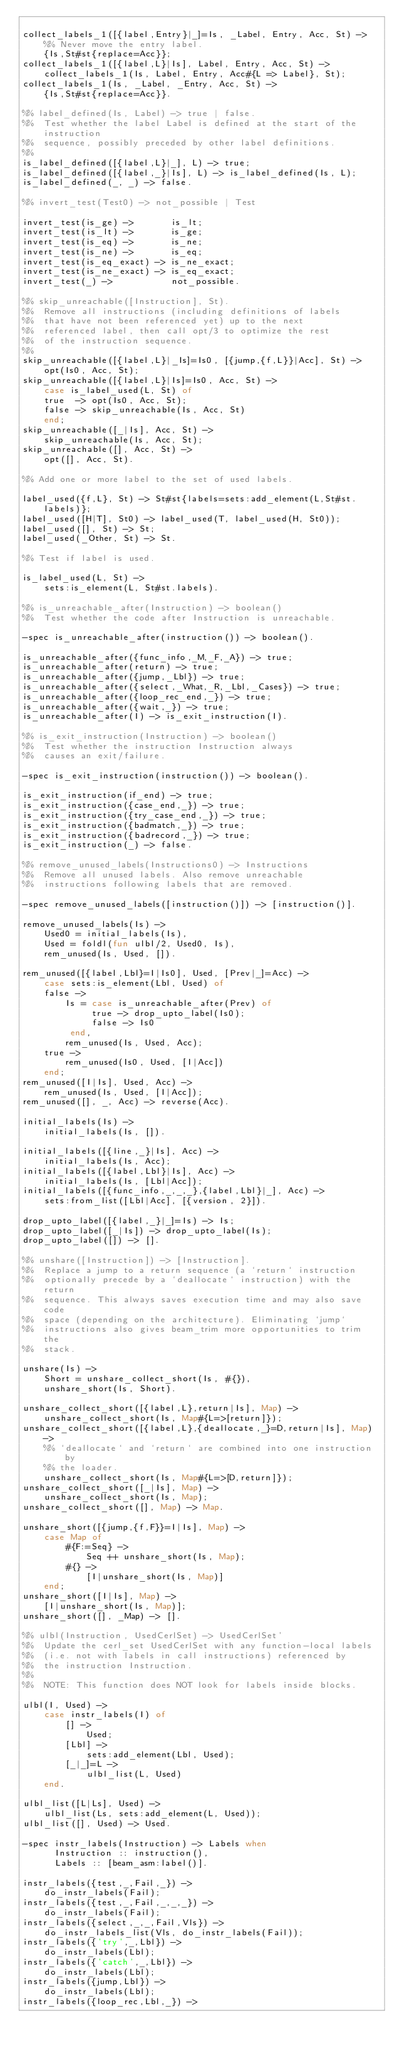Convert code to text. <code><loc_0><loc_0><loc_500><loc_500><_Erlang_>
collect_labels_1([{label,Entry}|_]=Is, _Label, Entry, Acc, St) ->
    %% Never move the entry label.
    {Is,St#st{replace=Acc}};
collect_labels_1([{label,L}|Is], Label, Entry, Acc, St) ->
    collect_labels_1(Is, Label, Entry, Acc#{L => Label}, St);
collect_labels_1(Is, _Label, _Entry, Acc, St) ->
    {Is,St#st{replace=Acc}}.

%% label_defined(Is, Label) -> true | false.
%%  Test whether the label Label is defined at the start of the instruction
%%  sequence, possibly preceded by other label definitions.
%%
is_label_defined([{label,L}|_], L) -> true;
is_label_defined([{label,_}|Is], L) -> is_label_defined(Is, L);
is_label_defined(_, _) -> false.

%% invert_test(Test0) -> not_possible | Test

invert_test(is_ge) ->       is_lt;
invert_test(is_lt) ->       is_ge;
invert_test(is_eq) ->       is_ne;
invert_test(is_ne) ->       is_eq;
invert_test(is_eq_exact) -> is_ne_exact;
invert_test(is_ne_exact) -> is_eq_exact;
invert_test(_) ->           not_possible.

%% skip_unreachable([Instruction], St).
%%  Remove all instructions (including definitions of labels
%%  that have not been referenced yet) up to the next
%%  referenced label, then call opt/3 to optimize the rest
%%  of the instruction sequence.
%%
skip_unreachable([{label,L}|_Is]=Is0, [{jump,{f,L}}|Acc], St) ->
    opt(Is0, Acc, St);
skip_unreachable([{label,L}|Is]=Is0, Acc, St) ->
    case is_label_used(L, St) of
	true  -> opt(Is0, Acc, St);
	false -> skip_unreachable(Is, Acc, St)
    end;
skip_unreachable([_|Is], Acc, St) ->
    skip_unreachable(Is, Acc, St);
skip_unreachable([], Acc, St) ->
    opt([], Acc, St).

%% Add one or more label to the set of used labels.

label_used({f,L}, St) -> St#st{labels=sets:add_element(L,St#st.labels)};
label_used([H|T], St0) -> label_used(T, label_used(H, St0));
label_used([], St) -> St;
label_used(_Other, St) -> St.

%% Test if label is used.

is_label_used(L, St) ->
    sets:is_element(L, St#st.labels).

%% is_unreachable_after(Instruction) -> boolean()
%%  Test whether the code after Instruction is unreachable.

-spec is_unreachable_after(instruction()) -> boolean().

is_unreachable_after({func_info,_M,_F,_A}) -> true;
is_unreachable_after(return) -> true;
is_unreachable_after({jump,_Lbl}) -> true;
is_unreachable_after({select,_What,_R,_Lbl,_Cases}) -> true;
is_unreachable_after({loop_rec_end,_}) -> true;
is_unreachable_after({wait,_}) -> true;
is_unreachable_after(I) -> is_exit_instruction(I).

%% is_exit_instruction(Instruction) -> boolean()
%%  Test whether the instruction Instruction always
%%  causes an exit/failure.

-spec is_exit_instruction(instruction()) -> boolean().

is_exit_instruction(if_end) -> true;
is_exit_instruction({case_end,_}) -> true;
is_exit_instruction({try_case_end,_}) -> true;
is_exit_instruction({badmatch,_}) -> true;
is_exit_instruction({badrecord,_}) -> true;
is_exit_instruction(_) -> false.

%% remove_unused_labels(Instructions0) -> Instructions
%%  Remove all unused labels. Also remove unreachable
%%  instructions following labels that are removed.

-spec remove_unused_labels([instruction()]) -> [instruction()].

remove_unused_labels(Is) ->
    Used0 = initial_labels(Is),
    Used = foldl(fun ulbl/2, Used0, Is),
    rem_unused(Is, Used, []).

rem_unused([{label,Lbl}=I|Is0], Used, [Prev|_]=Acc) ->
    case sets:is_element(Lbl, Used) of
	false ->
	    Is = case is_unreachable_after(Prev) of
		     true -> drop_upto_label(Is0);
		     false -> Is0
		 end,
	    rem_unused(Is, Used, Acc);
	true ->
	    rem_unused(Is0, Used, [I|Acc])
    end;
rem_unused([I|Is], Used, Acc) ->
    rem_unused(Is, Used, [I|Acc]);
rem_unused([], _, Acc) -> reverse(Acc).

initial_labels(Is) ->
    initial_labels(Is, []).

initial_labels([{line,_}|Is], Acc) ->
    initial_labels(Is, Acc);
initial_labels([{label,Lbl}|Is], Acc) ->
    initial_labels(Is, [Lbl|Acc]);
initial_labels([{func_info,_,_,_},{label,Lbl}|_], Acc) ->
    sets:from_list([Lbl|Acc], [{version, 2}]).

drop_upto_label([{label,_}|_]=Is) -> Is;
drop_upto_label([_|Is]) -> drop_upto_label(Is);
drop_upto_label([]) -> [].

%% unshare([Instruction]) -> [Instruction].
%%  Replace a jump to a return sequence (a `return` instruction
%%  optionally precede by a `deallocate` instruction) with the return
%%  sequence. This always saves execution time and may also save code
%%  space (depending on the architecture). Eliminating `jump`
%%  instructions also gives beam_trim more opportunities to trim the
%%  stack.

unshare(Is) ->
    Short = unshare_collect_short(Is, #{}),
    unshare_short(Is, Short).

unshare_collect_short([{label,L},return|Is], Map) ->
    unshare_collect_short(Is, Map#{L=>[return]});
unshare_collect_short([{label,L},{deallocate,_}=D,return|Is], Map) ->
    %% `deallocate` and `return` are combined into one instruction by
    %% the loader.
    unshare_collect_short(Is, Map#{L=>[D,return]});
unshare_collect_short([_|Is], Map) ->
    unshare_collect_short(Is, Map);
unshare_collect_short([], Map) -> Map.

unshare_short([{jump,{f,F}}=I|Is], Map) ->
    case Map of
        #{F:=Seq} ->
            Seq ++ unshare_short(Is, Map);
        #{} ->
            [I|unshare_short(Is, Map)]
    end;
unshare_short([I|Is], Map) ->
    [I|unshare_short(Is, Map)];
unshare_short([], _Map) -> [].

%% ulbl(Instruction, UsedCerlSet) -> UsedCerlSet'
%%  Update the cerl_set UsedCerlSet with any function-local labels
%%  (i.e. not with labels in call instructions) referenced by
%%  the instruction Instruction.
%%
%%  NOTE: This function does NOT look for labels inside blocks.

ulbl(I, Used) ->
    case instr_labels(I) of
        [] ->
            Used;
        [Lbl] ->
            sets:add_element(Lbl, Used);
        [_|_]=L ->
            ulbl_list(L, Used)
    end.

ulbl_list([L|Ls], Used) ->
    ulbl_list(Ls, sets:add_element(L, Used));
ulbl_list([], Used) -> Used.

-spec instr_labels(Instruction) -> Labels when
      Instruction :: instruction(),
      Labels :: [beam_asm:label()].

instr_labels({test,_,Fail,_}) ->
    do_instr_labels(Fail);
instr_labels({test,_,Fail,_,_,_}) ->
    do_instr_labels(Fail);
instr_labels({select,_,_,Fail,Vls}) ->
    do_instr_labels_list(Vls, do_instr_labels(Fail));
instr_labels({'try',_,Lbl}) ->
    do_instr_labels(Lbl);
instr_labels({'catch',_,Lbl}) ->
    do_instr_labels(Lbl);
instr_labels({jump,Lbl}) ->
    do_instr_labels(Lbl);
instr_labels({loop_rec,Lbl,_}) -></code> 